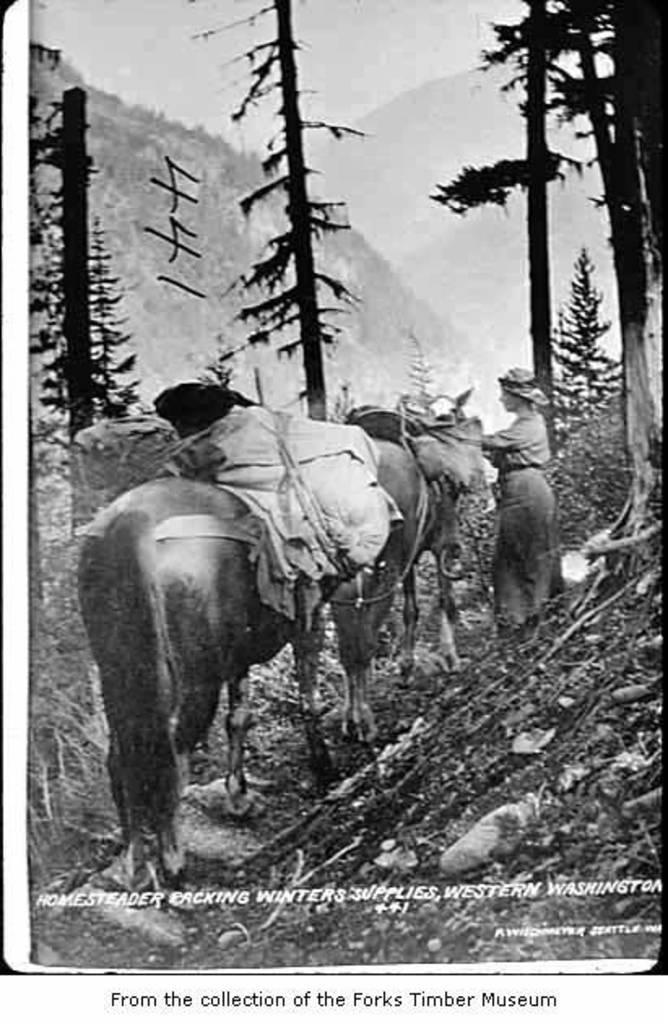What types of living organisms are present in the image? There are animals in the image. Can you describe the human presence in the image? There is a person standing in the image. What can be seen in the background of the image? There are trees in the background of the image. What is the color scheme of the image? The image is in black and white. What type of lumber is being used by the animals in the image? There is no lumber present in the image, as it features animals and a person in a black and white setting. 